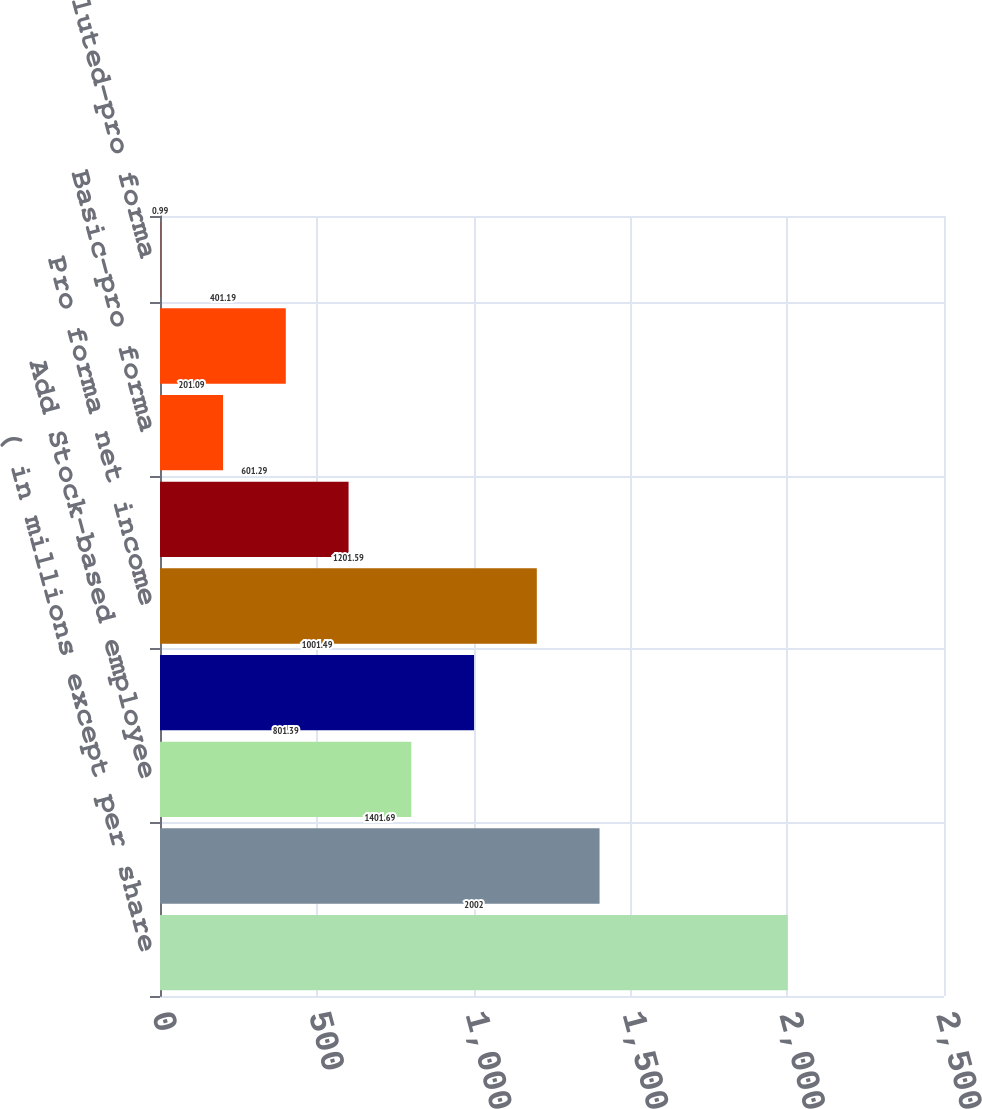Convert chart. <chart><loc_0><loc_0><loc_500><loc_500><bar_chart><fcel>( in millions except per share<fcel>Net income as reported<fcel>Add Stock-based employee<fcel>Deduct Total stock-based<fcel>Pro forma net income<fcel>Basic-as reported<fcel>Basic-pro forma<fcel>Diluted-as reported<fcel>Diluted-pro forma<nl><fcel>2002<fcel>1401.69<fcel>801.39<fcel>1001.49<fcel>1201.59<fcel>601.29<fcel>201.09<fcel>401.19<fcel>0.99<nl></chart> 